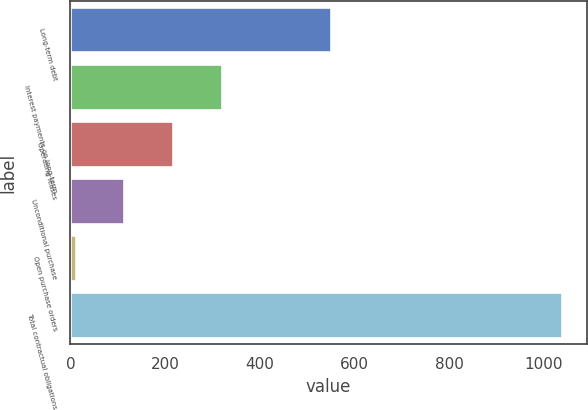<chart> <loc_0><loc_0><loc_500><loc_500><bar_chart><fcel>Long-term debt<fcel>Interest payments on long-term<fcel>Operating leases<fcel>Unconditional purchase<fcel>Open purchase orders<fcel>Total contractual obligations<nl><fcel>550<fcel>319.4<fcel>216.6<fcel>113.8<fcel>11<fcel>1039<nl></chart> 